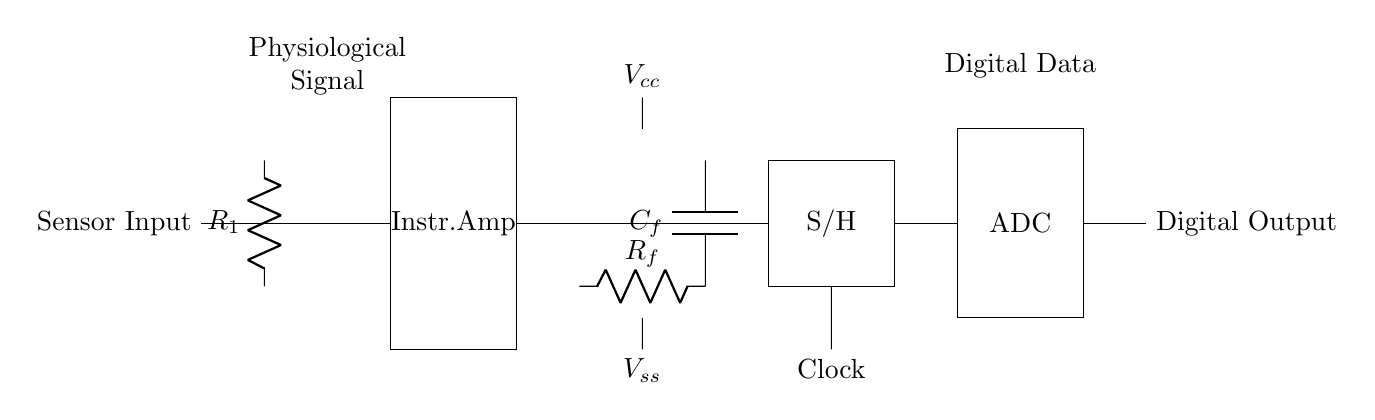What is the first component in the circuit? The first component in the circuit is the resistor labeled R1, which acts as a current limiting device for the sensor input.
Answer: R1 What is the function of the instrumentation amplifier? The instrumentation amplifier amplifies the physiological signal received from the sensor while rejecting noise and interference, providing a higher amplitude signal for further processing.
Answer: Amplification What type of filter is used in this circuit? The circuit includes a low-pass filter formed by the resistor Rf and capacitor Cf, which allows low-frequency signals to pass while attenuating high-frequency noise.
Answer: Low-pass filter What is the role of the sample and hold section? The sample and hold section captures the voltage of the signal at a specific moment in time, allowing the analog signal to be held steady for accurate conversion by the ADC.
Answer: Voltage stabilization How does this circuit convert an analog signal to a digital one? The circuit includes an analog-to-digital converter (ADC) that quantizes the held analog voltage into discrete digital values, enabling the representation of the signal in a digital format for analysis or processing in digital systems.
Answer: ADC conversion What are the power supply voltages indicated in the circuit? The circuit indicates a positive power supply voltage labeled Vcc at the top and a negative supply voltage labeled Vss at the bottom, which provide the necessary operating conditions for the amplifiers and ADC.
Answer: Vcc and Vss 